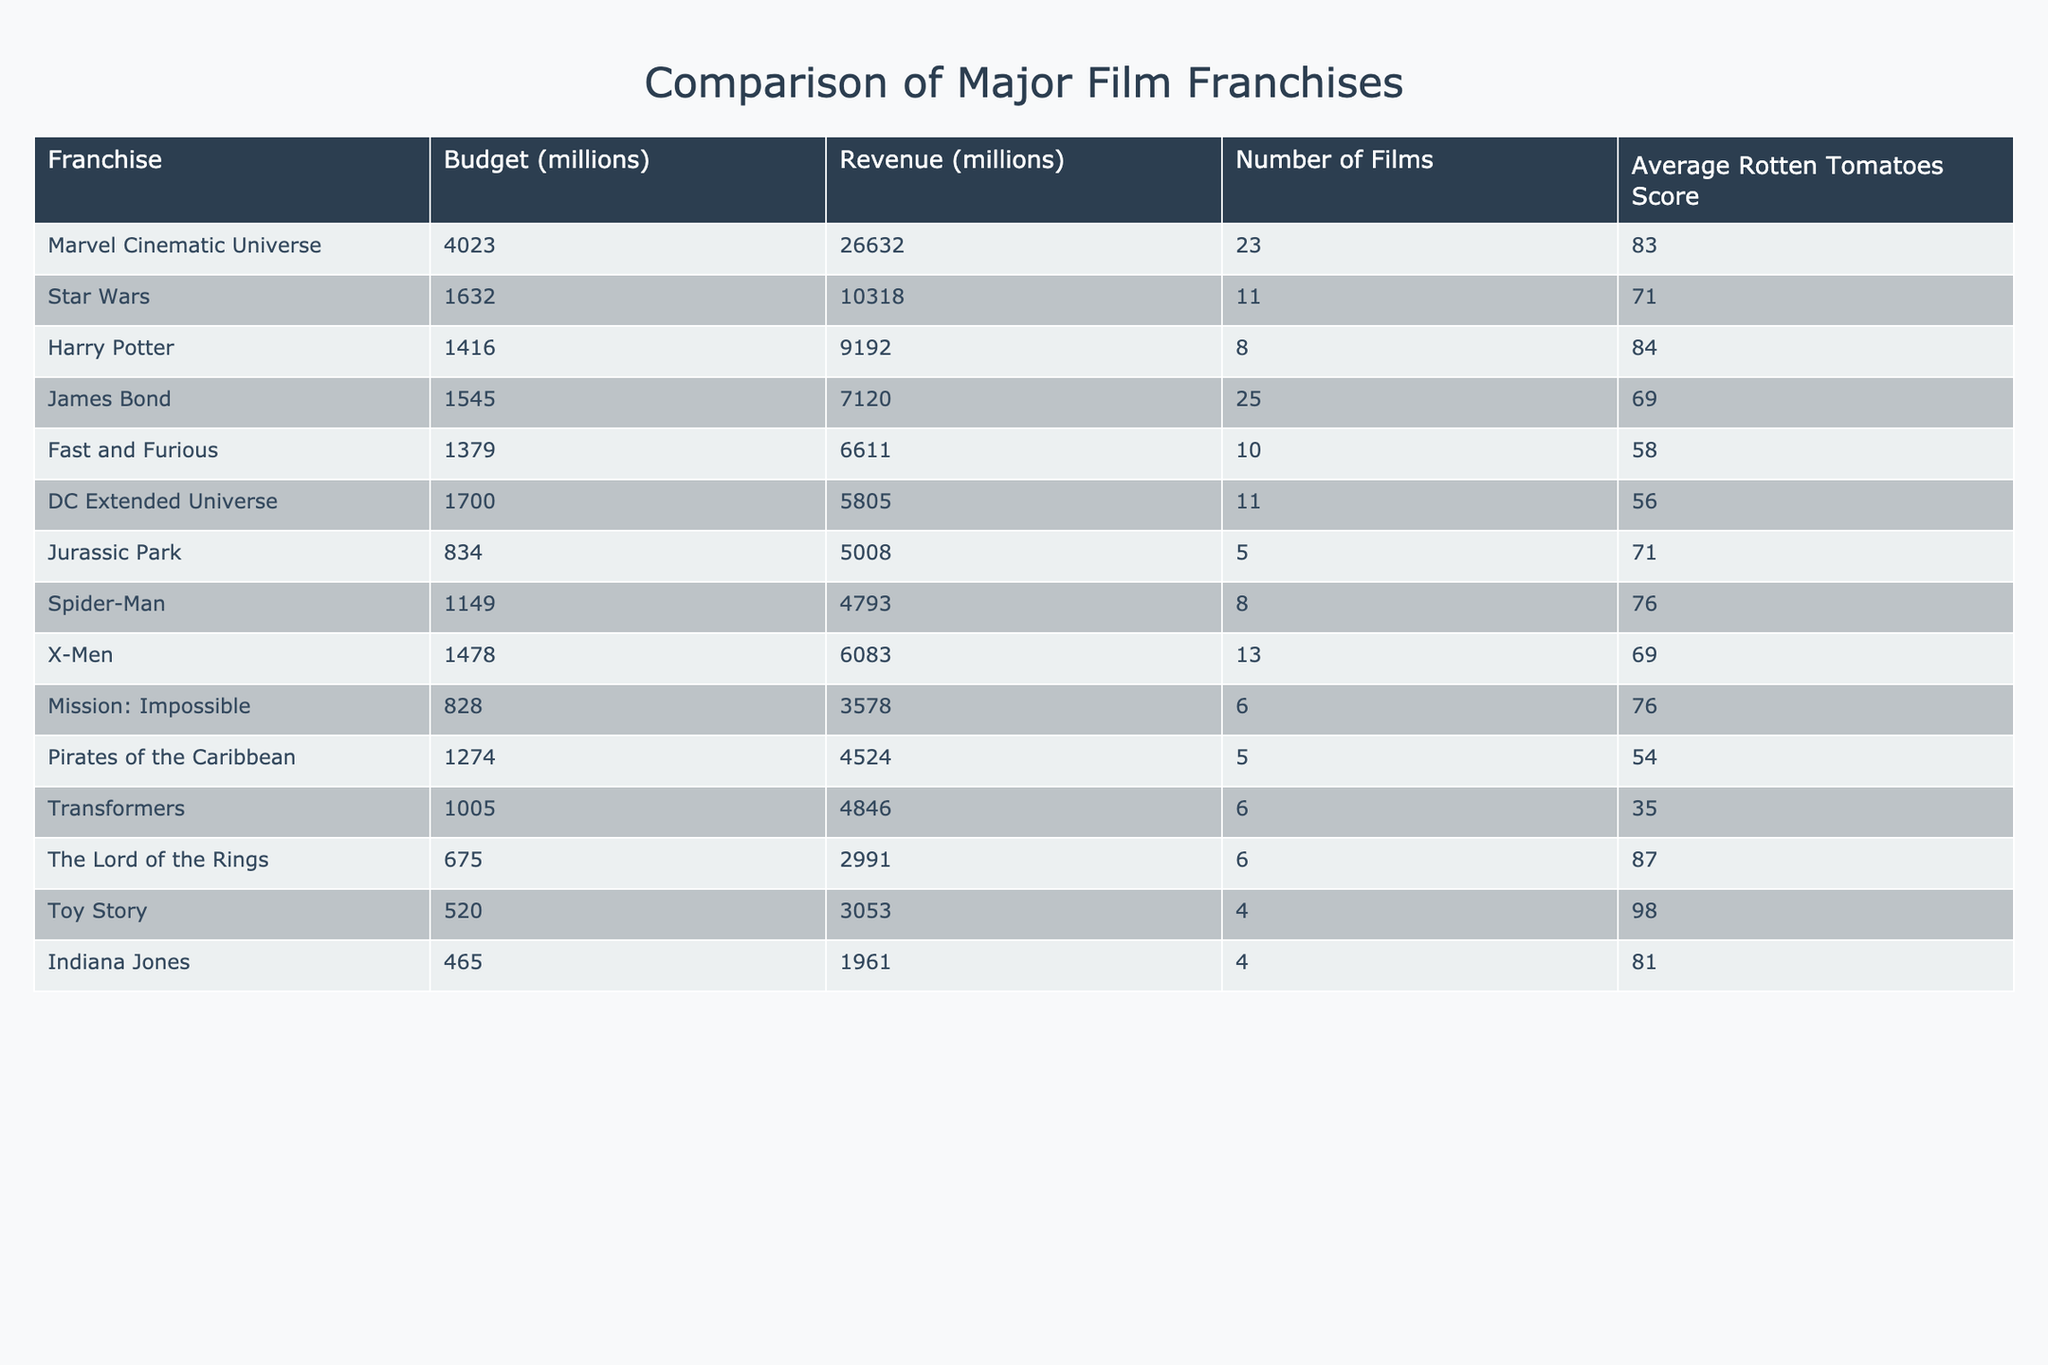What is the total budget for the Marvel Cinematic Universe franchise? The budget for the Marvel Cinematic Universe is listed as 4023 million dollars.
Answer: 4023 million dollars Which film franchise has the highest revenue? The franchise with the highest revenue is the Marvel Cinematic Universe, with a revenue of 26632 million dollars.
Answer: Marvel Cinematic Universe How many films are in the Star Wars franchise? The Star Wars franchise has 11 films according to the table.
Answer: 11 films What is the average Rotten Tomatoes score for the Harry Potter franchise? The average Rotten Tomatoes score for the Harry Potter franchise is 84 as shown in the table.
Answer: 84 What is the budget difference between the DC Extended Universe and the Fast and Furious franchise? The DC Extended Universe has a budget of 1700 million dollars, while the Fast and Furious franchise has a budget of 1379 million dollars. The difference is 1700 - 1379 = 321 million dollars.
Answer: 321 million dollars Which franchise has the lowest average Rotten Tomatoes score? The franchise with the lowest average Rotten Tomatoes score is Transformers, with a score of 35.
Answer: Transformers If you add the budget of James Bond and Harry Potter franchises, what is the total? The budget for James Bond is 1545 million dollars and for Harry Potter is 1416 million dollars. The total budget is calculated as 1545 + 1416 = 2961 million dollars.
Answer: 2961 million dollars Does the Spider-Man franchise have a higher revenue than the Pirates of the Caribbean franchise? The Spider-Man franchise has a revenue of 4793 million dollars, while Pirates of the Caribbean has a revenue of 4524 million dollars. Therefore, yes, Spider-Man has a higher revenue.
Answer: Yes Which franchise has the lowest revenue per film? The revenue per film for each franchise is calculated by dividing the total revenue by the number of films. For Transformers, it is 4846 million divided by 6 films = 807.67 million per film, which is the lowest compared to others.
Answer: Transformers If you rank the franchises by budget, which one is in the fifth position? The budgets in descending order result in Marvel Cinematic Universe, Star Wars, Harry Potter, James Bond, and then Fast and Furious. Hence, Fast and Furious is in the fifth position.
Answer: Fast and Furious 